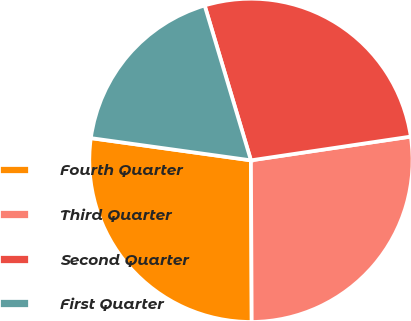Convert chart to OTSL. <chart><loc_0><loc_0><loc_500><loc_500><pie_chart><fcel>Fourth Quarter<fcel>Third Quarter<fcel>Second Quarter<fcel>First Quarter<nl><fcel>27.27%<fcel>27.27%<fcel>27.27%<fcel>18.18%<nl></chart> 